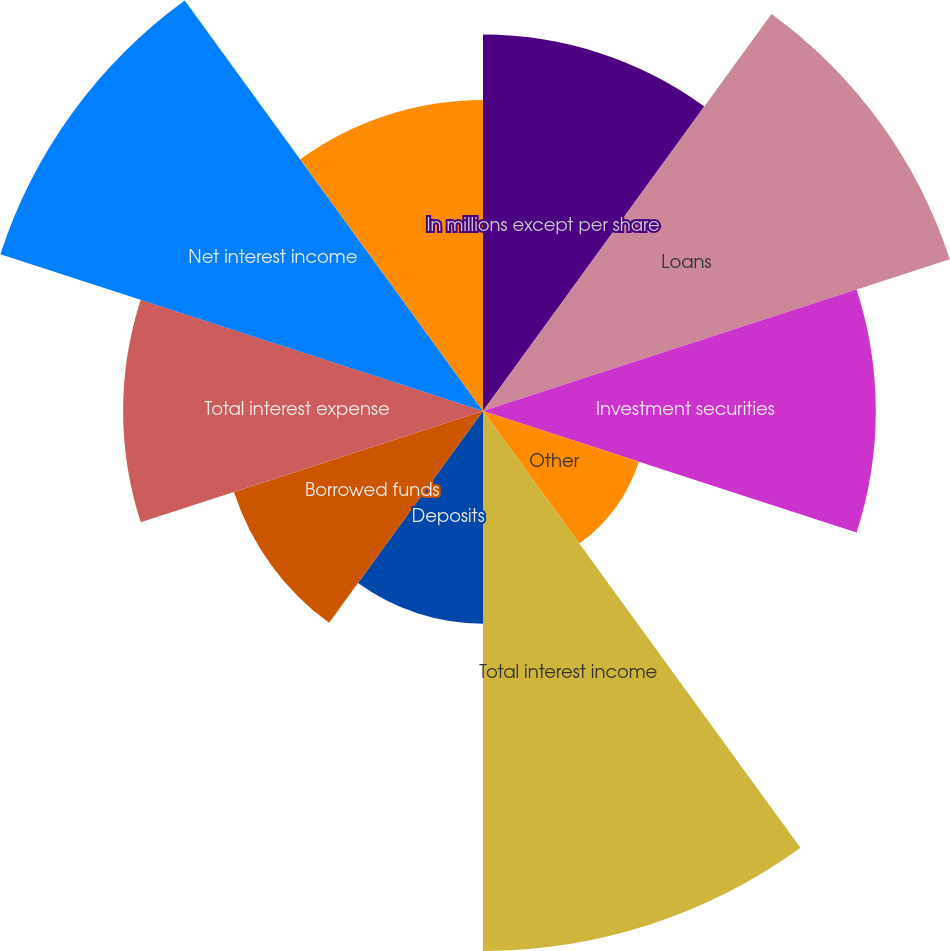<chart> <loc_0><loc_0><loc_500><loc_500><pie_chart><fcel>In millions except per share<fcel>Loans<fcel>Investment securities<fcel>Other<fcel>Total interest income<fcel>Deposits<fcel>Borrowed funds<fcel>Total interest expense<fcel>Net interest income<fcel>Asset management<nl><fcel>10.41%<fcel>13.57%<fcel>10.86%<fcel>4.53%<fcel>14.93%<fcel>5.88%<fcel>7.24%<fcel>9.95%<fcel>14.03%<fcel>8.6%<nl></chart> 